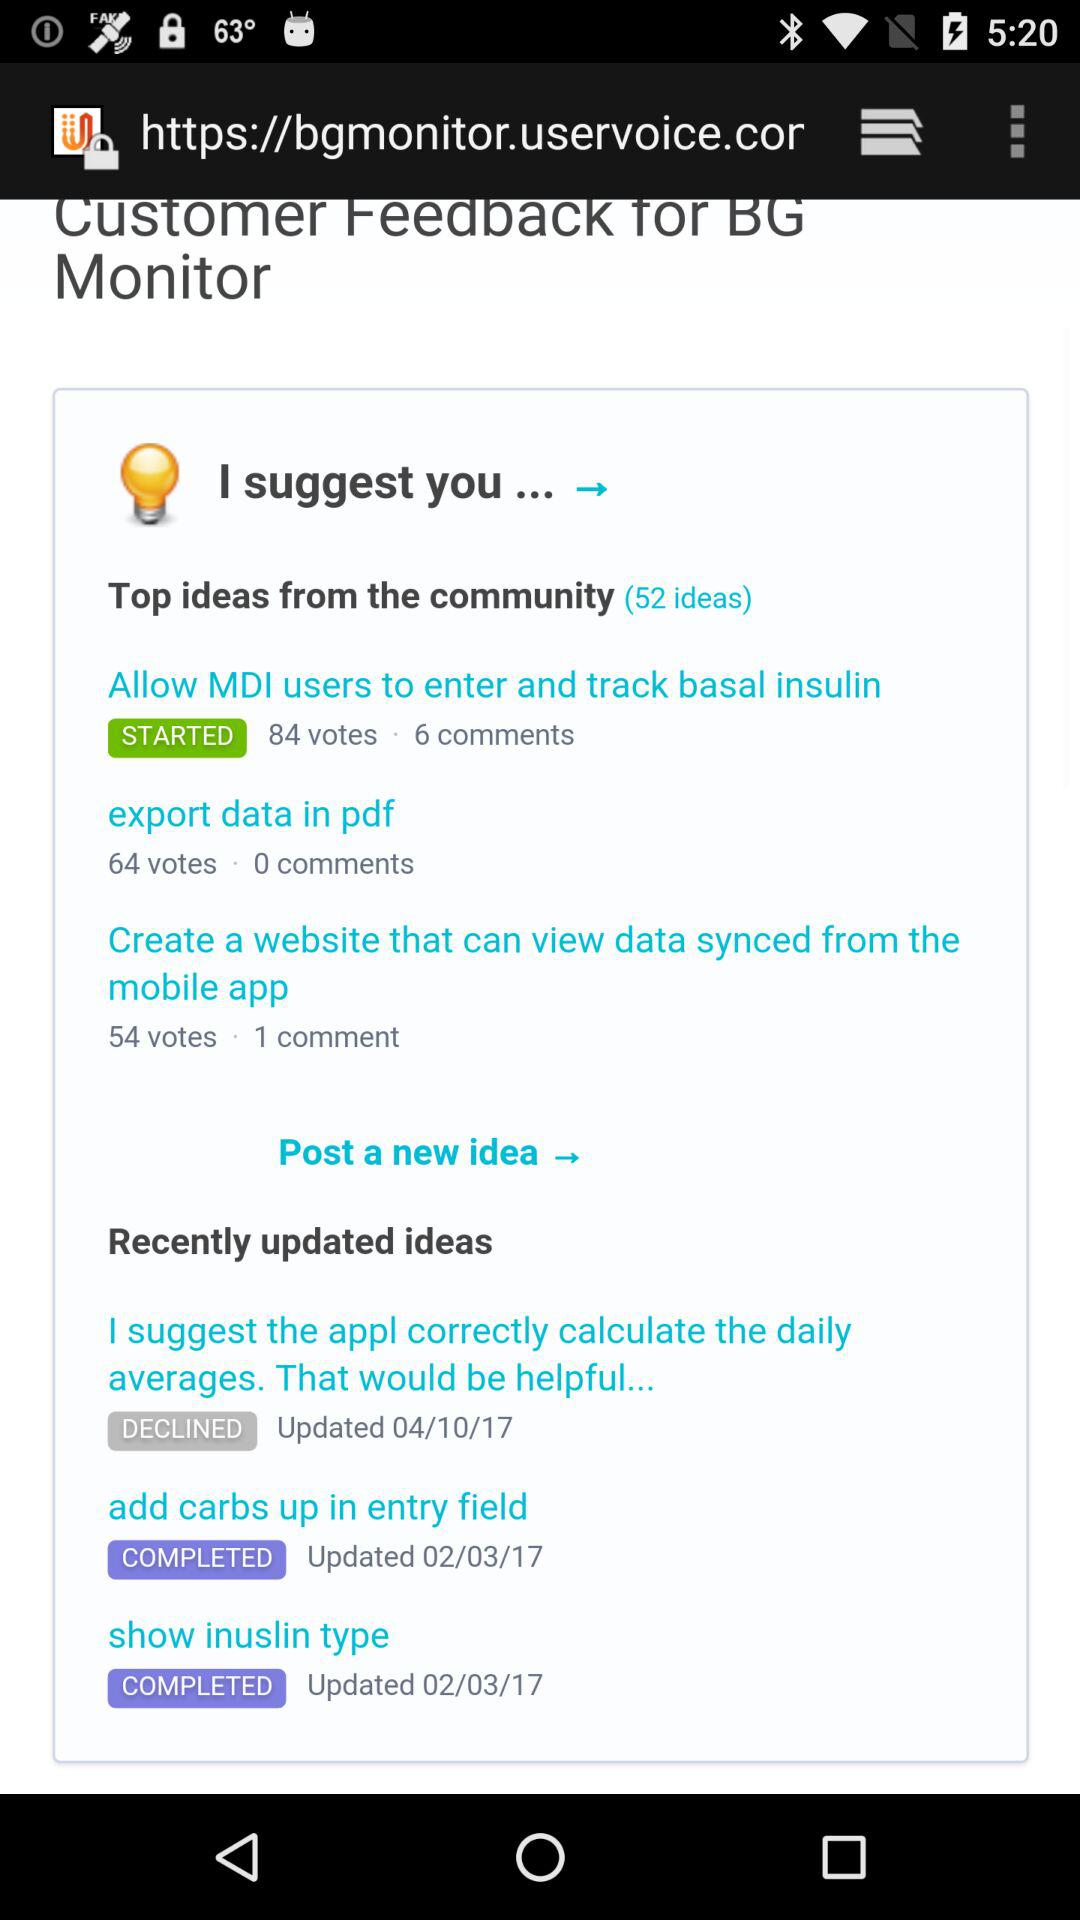How many votes are there for the idea 'Allow MDI users to enter and track basal insulin'?
Answer the question using a single word or phrase. 84 